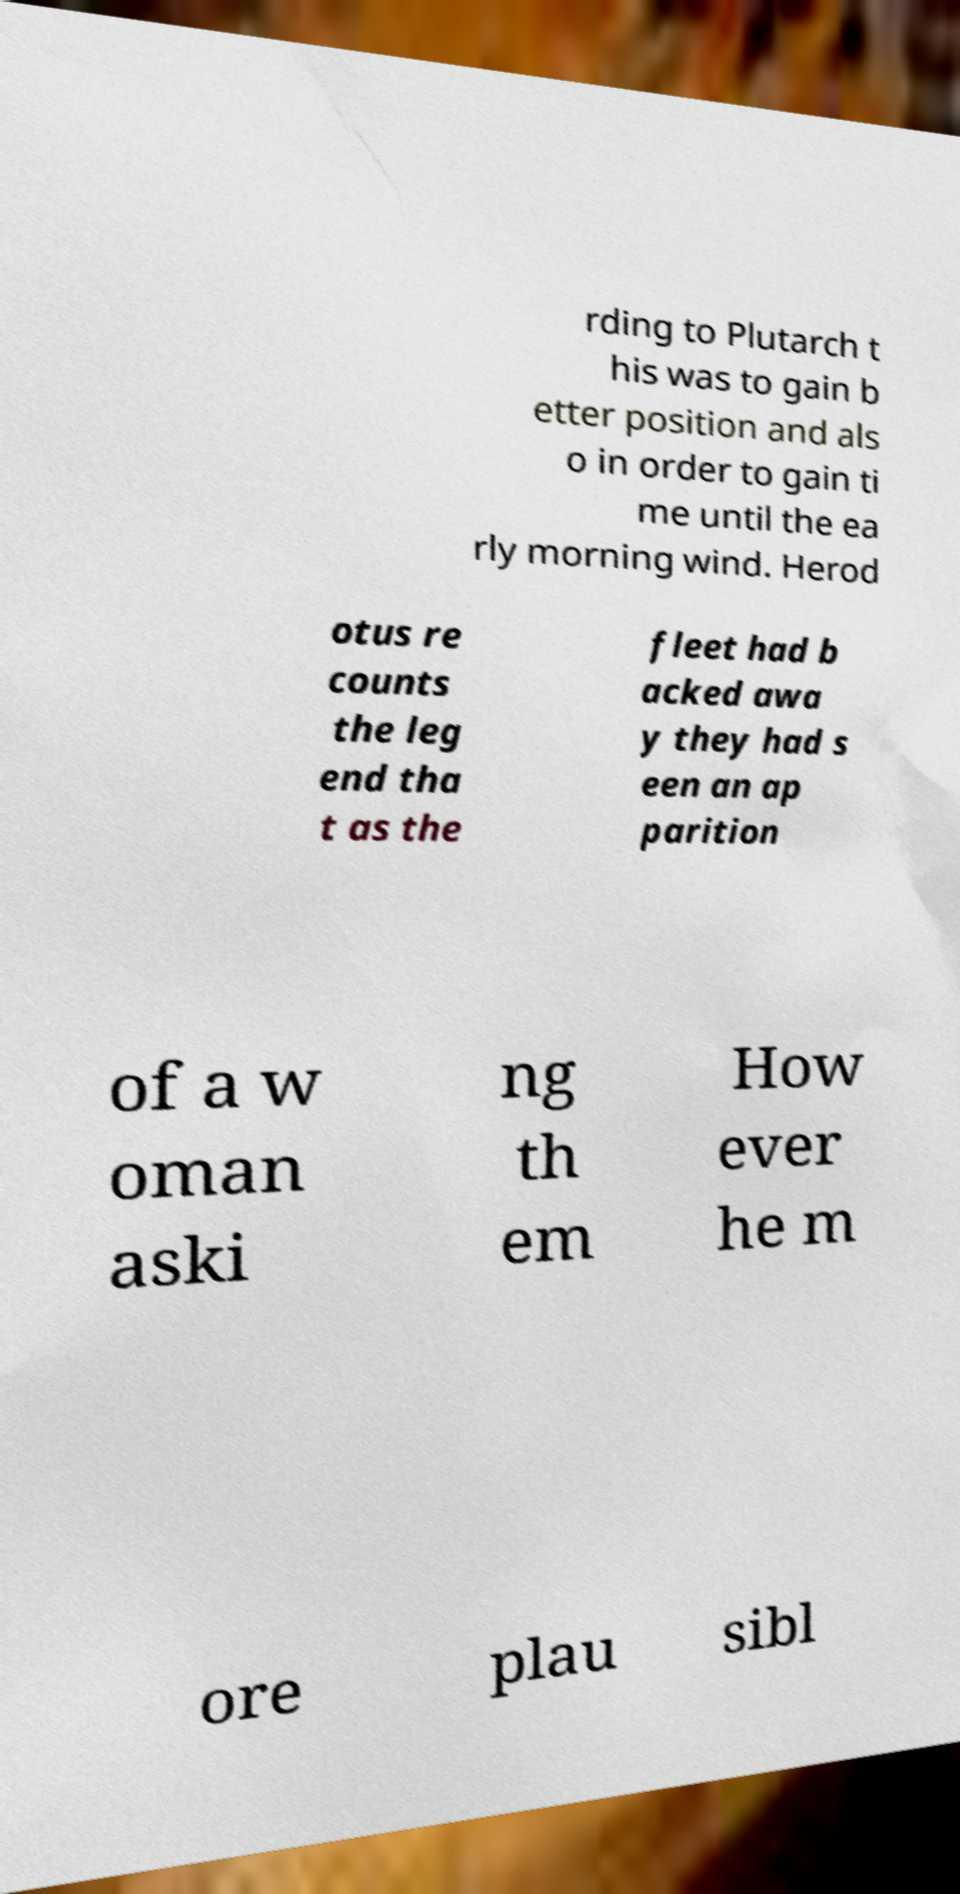Please read and relay the text visible in this image. What does it say? rding to Plutarch t his was to gain b etter position and als o in order to gain ti me until the ea rly morning wind. Herod otus re counts the leg end tha t as the fleet had b acked awa y they had s een an ap parition of a w oman aski ng th em How ever he m ore plau sibl 